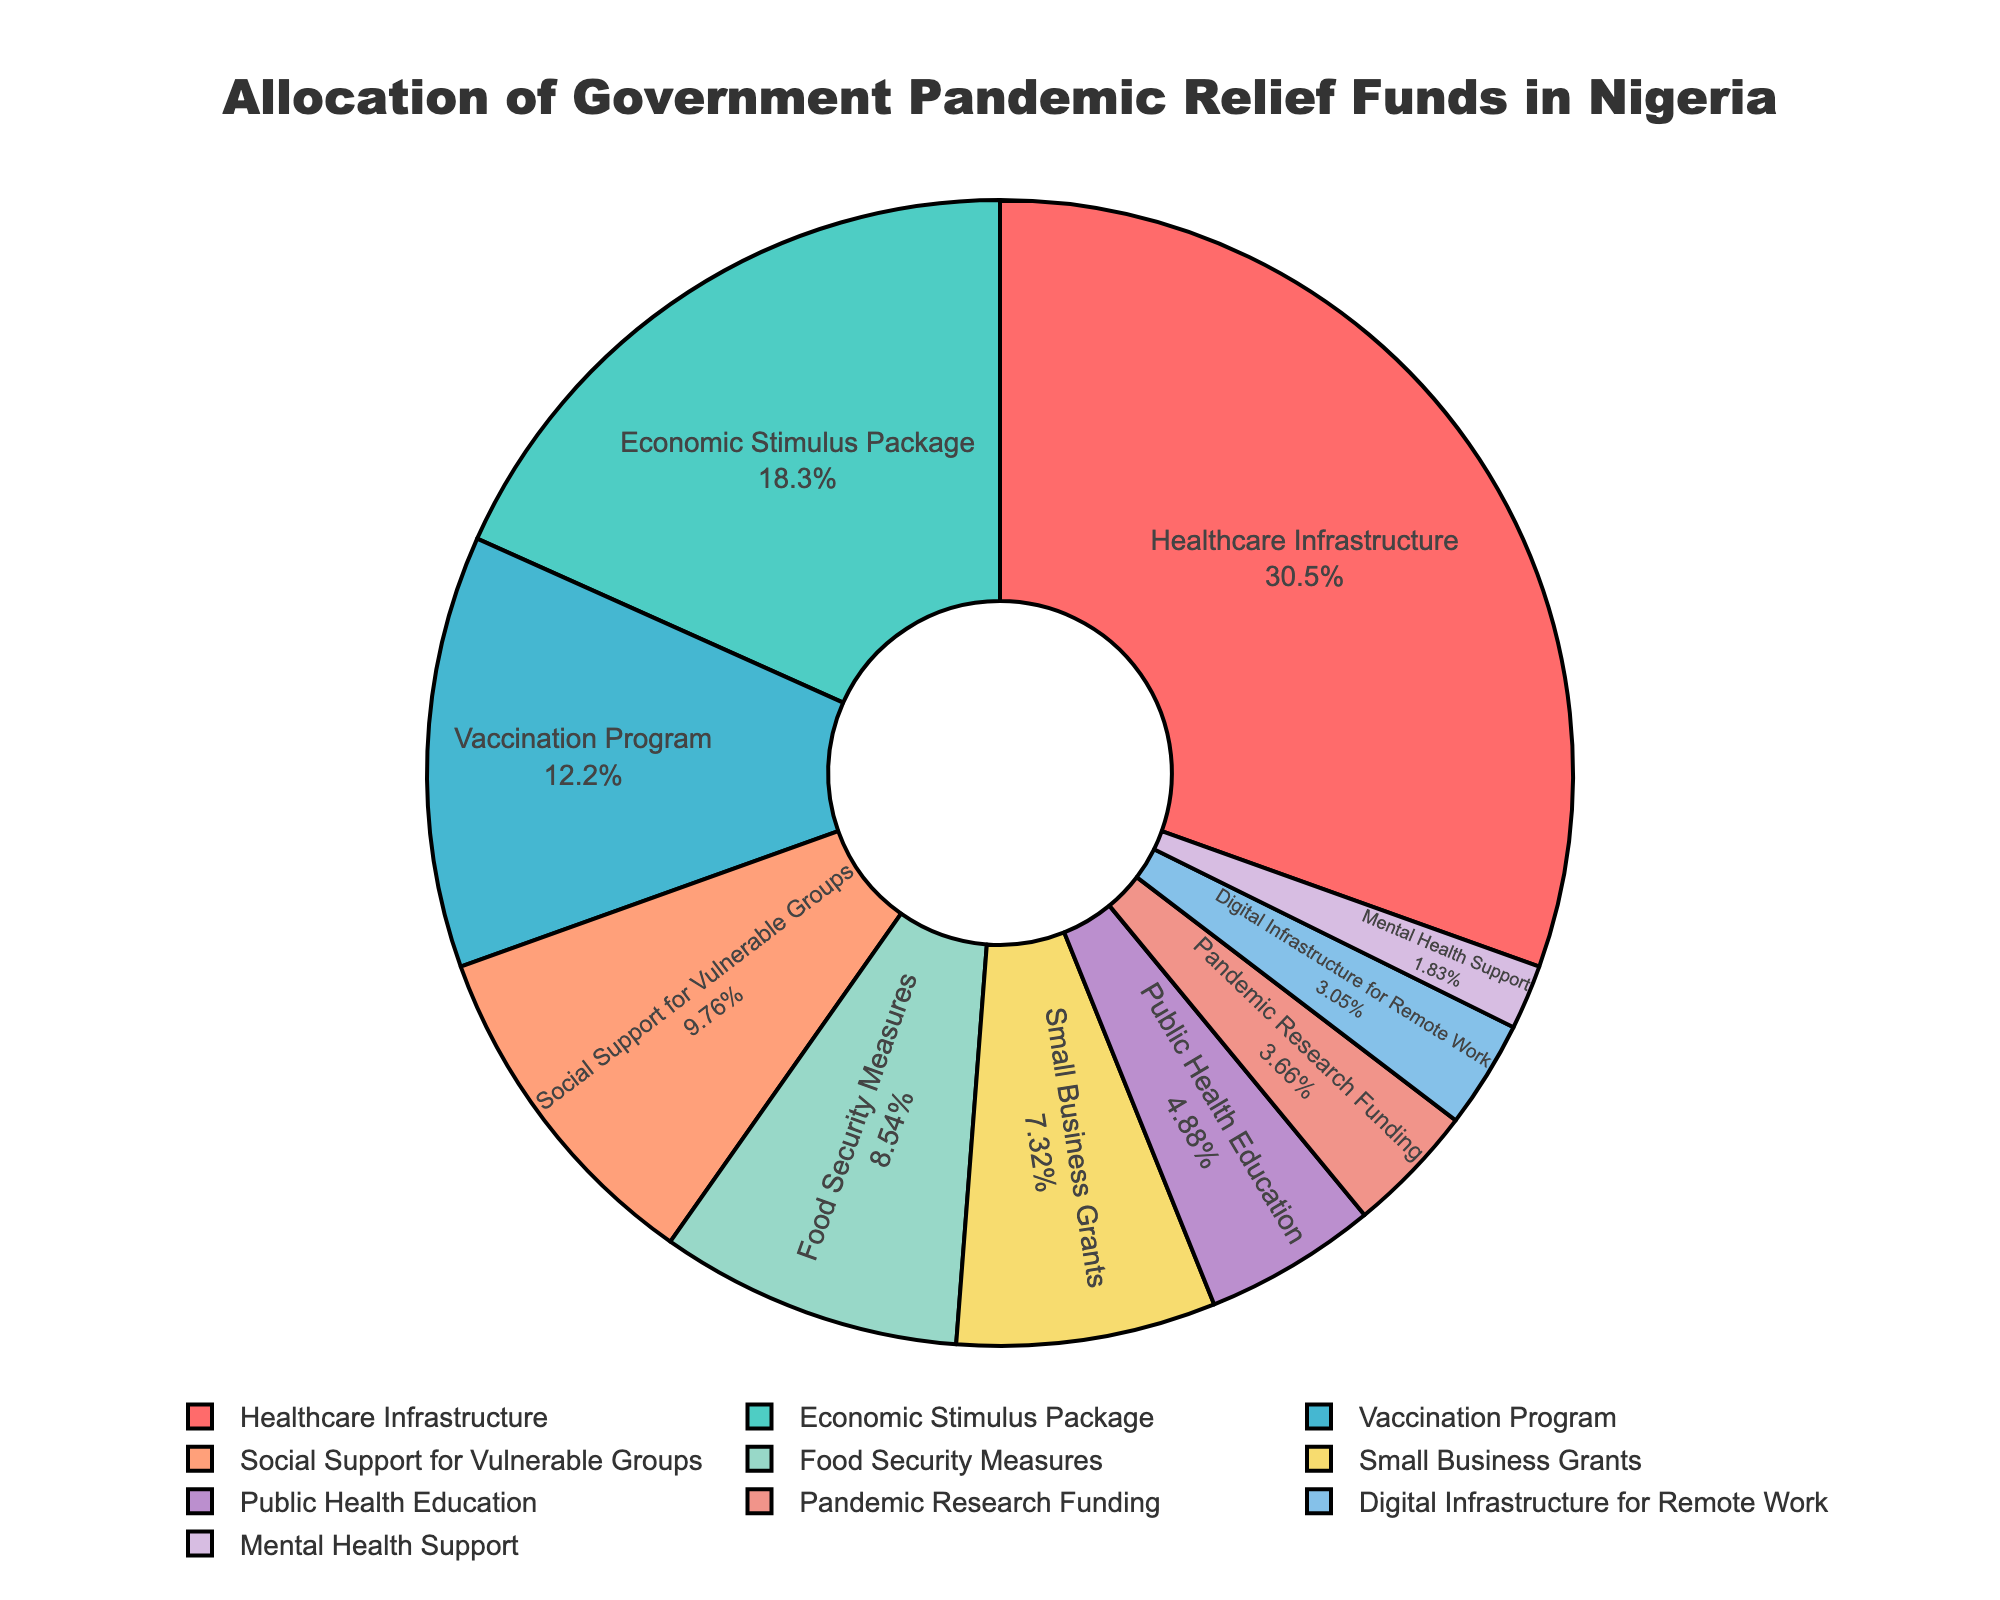what percentage of the funds are allocated to healthcare infrastructure? The slice representing "Healthcare Infrastructure" shows both the label and the percentage, which is displayed inside the slice. By looking at the figure, you can see the percentage value inside the label "Healthcare Infrastructure".
Answer: 35.71% which category receives the lowest amount of funds? The pie chart shows slices with differing sizes. The smallest slice represents the category with the least funds allocated. By looking at the figure, you can identify the smallest slice.
Answer: Mental Health Support how much more is allocated to the economic stimulus package compared to the vaccination program? The Economic Stimulus Package and Vaccination Program have specific amounts labeled in the figure. By identifying their values, calculate the difference: 150 - 100 = 50 billion Naira.
Answer: 50 billion Naira which category receives more funds: small business grants or public health education? Compare the sizes and labels of the slices representing "Small Business Grants" and "Public Health Education". The figure shows that Small Business Grants have a larger slice compared to Public Health Education.
Answer: Small Business Grants what is the combined percentage allocation for food security measures and pandemic research funding? The pie chart shows the individual percentages for Food Security Measures and Pandemic Research Funding. Add these percentages together by identifying them from the figure: (10.00% + 4.29% = 14.29%).
Answer: 14.29% what is the total fund allocated for categories receiving less than 50 billion naira each? The categories receiving less than 50 billion Naira are "Digital Infrastructure for Remote Work" (25 billion), "Mental Health Support" (15 billion), and "Pandemic Research Funding" (30 billion). Summing these gives 25 + 15 + 30 = 70 billion Naira.
Answer: 70 billion Naira how do the funds allocated to healthcare infrastructure compare visually to those allocated to public health education? Look at the size and color of the slices representing "Healthcare Infrastructure" and "Public Health Education". "Healthcare Infrastructure" has a much larger slice, indicating it receives more funds.
Answer: "Healthcare Infrastructure" receives more funds what percentage of the total funds are allocated to social support for vulnerable groups? The slice representing "Social Support for Vulnerable Groups" shows the percentage value inside the label in the figure. This label shows the required percentage.
Answer: 11.43% by how much does the allocation for economic stimulus package exceed that for small business grants? Identify the amounts for Economic Stimulus Package (150 billion) and Small Business Grants (60 billion). Calculate the difference: 150 - 60 = 90 billion Naira.
Answer: 90 billion Naira 